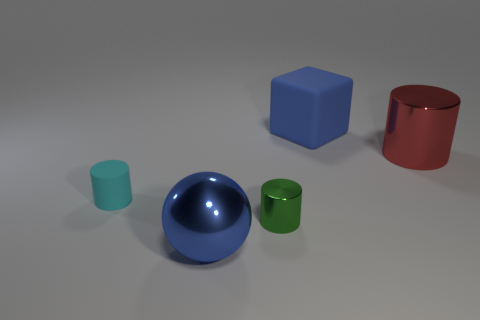What is the material of the small cyan thing?
Provide a short and direct response. Rubber. There is a big metallic thing that is in front of the cyan thing; is it the same color as the rubber thing that is right of the small green metal cylinder?
Give a very brief answer. Yes. Is the number of small green metal objects greater than the number of small cylinders?
Ensure brevity in your answer.  No. How many large rubber objects have the same color as the matte cube?
Offer a terse response. 0. There is another rubber object that is the same shape as the red thing; what color is it?
Keep it short and to the point. Cyan. There is a big object that is to the left of the red metal object and behind the cyan object; what material is it?
Provide a succinct answer. Rubber. Do the tiny thing in front of the small matte cylinder and the blue thing in front of the blue cube have the same material?
Provide a short and direct response. Yes. What size is the cyan rubber thing?
Provide a succinct answer. Small. There is a green shiny thing that is the same shape as the tiny matte thing; what is its size?
Make the answer very short. Small. There is a tiny green object; what number of cylinders are to the left of it?
Your response must be concise. 1. 